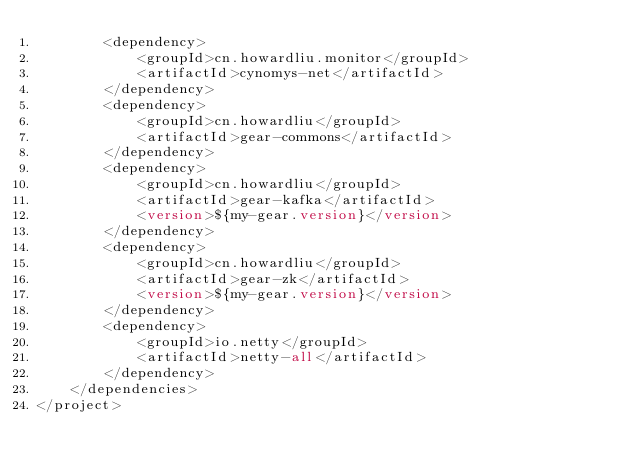Convert code to text. <code><loc_0><loc_0><loc_500><loc_500><_XML_>        <dependency>
            <groupId>cn.howardliu.monitor</groupId>
            <artifactId>cynomys-net</artifactId>
        </dependency>
        <dependency>
            <groupId>cn.howardliu</groupId>
            <artifactId>gear-commons</artifactId>
        </dependency>
        <dependency>
            <groupId>cn.howardliu</groupId>
            <artifactId>gear-kafka</artifactId>
            <version>${my-gear.version}</version>
        </dependency>
        <dependency>
            <groupId>cn.howardliu</groupId>
            <artifactId>gear-zk</artifactId>
            <version>${my-gear.version}</version>
        </dependency>
        <dependency>
            <groupId>io.netty</groupId>
            <artifactId>netty-all</artifactId>
        </dependency>
    </dependencies>
</project></code> 